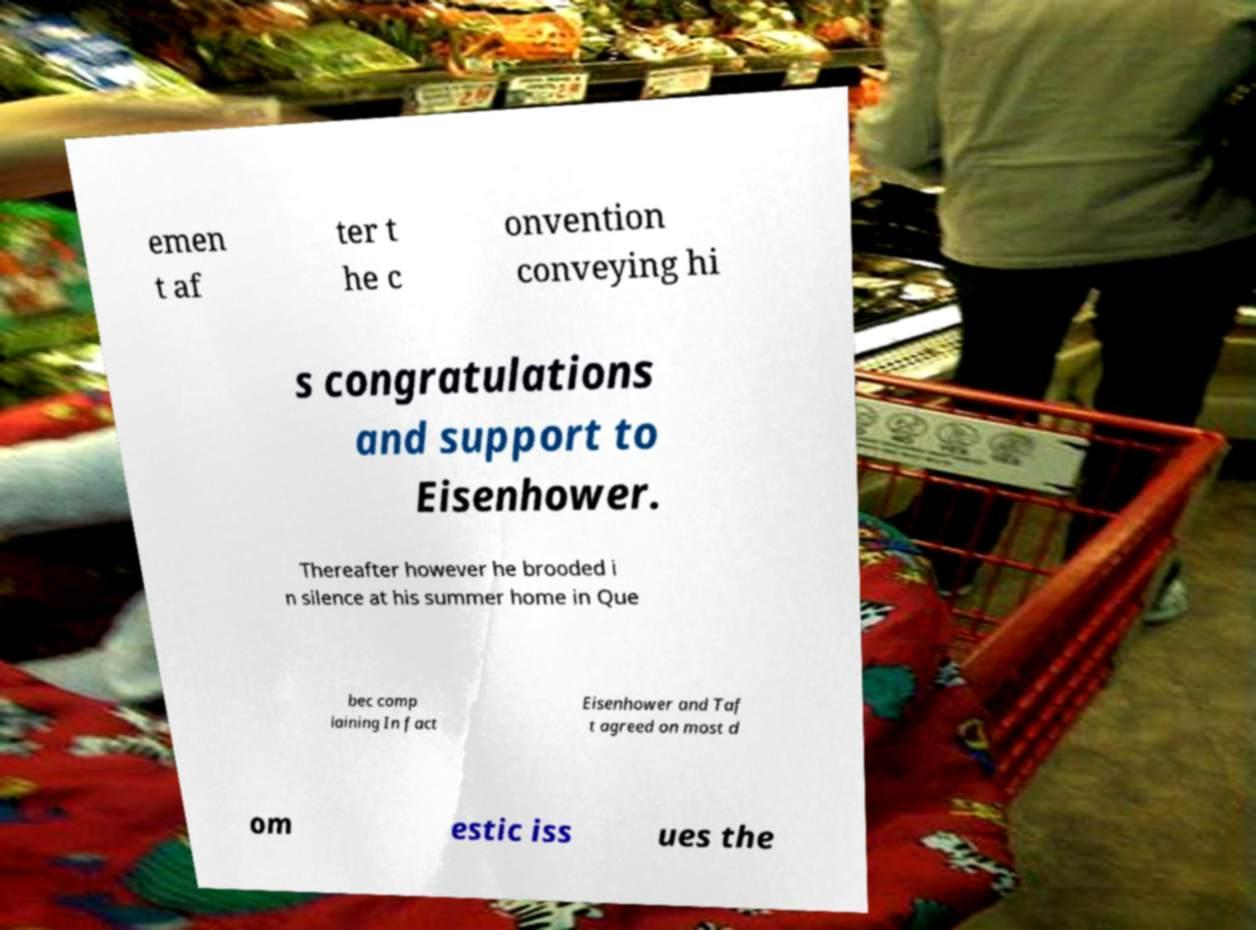Could you assist in decoding the text presented in this image and type it out clearly? emen t af ter t he c onvention conveying hi s congratulations and support to Eisenhower. Thereafter however he brooded i n silence at his summer home in Que bec comp laining In fact Eisenhower and Taf t agreed on most d om estic iss ues the 